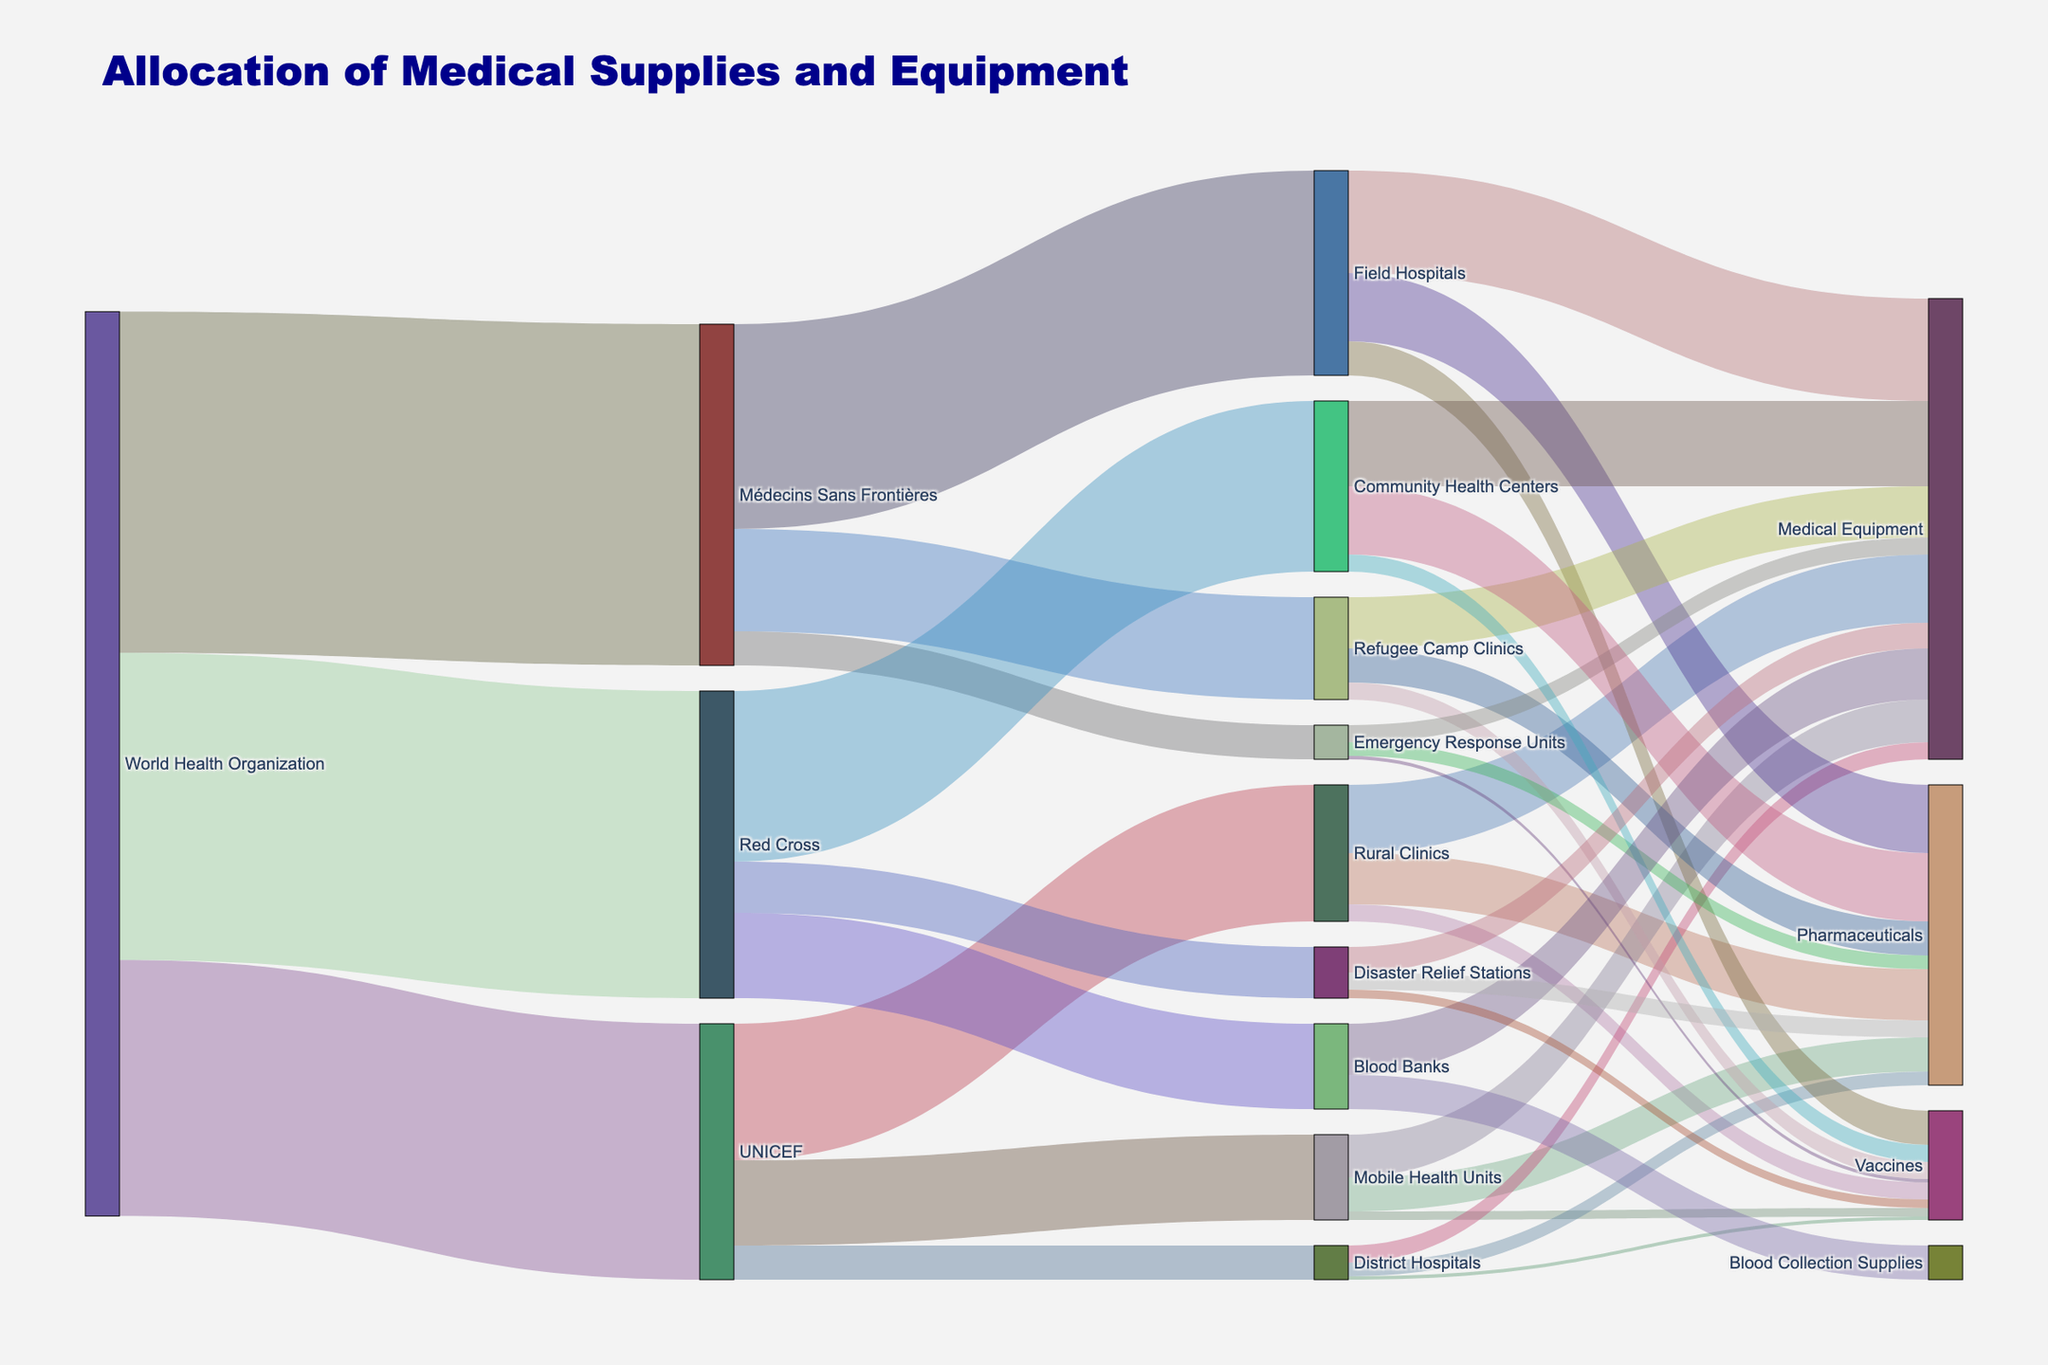Who allocates the most supplies to frontline health facilities? By visually inspecting the flow sizes in the Sankey Diagram, Médecins Sans Frontières allocates the most, as their combined flow to Field Hospitals, Refugee Camp Clinics, and Emergency Response Units is the largest.
Answer: Médecins Sans Frontières Which target facility receives the highest allocation from UNICEF? By inspecting the flows from UNICEF to its target facilities, Rural Clinics receive the highest allocation, indicated by the largest flow value.
Answer: Rural Clinics How much total value is allocated from the World Health Organization to its target organizations? Adding the flows from the World Health Organization to its targets: 1,500,000 + 2,000,000 + 1,800,000 = 5,300,000.
Answer: 5,300,000 Compare the allocation to Field Hospitals from Médecins Sans Frontières and the allocation to Community Health Centers from Red Cross. Which is higher and by how much? Médecins Sans Frontières allocates 1,200,000 to Field Hospitals, whereas Red Cross allocates 1,000,000 to Community Health Centers, resulting in a difference of 200,000.
Answer: Field Hospitals by 200,000 What is the smallest allocation made by UNICEF, and to which facility does it go? Checking the values of the flows from UNICEF, the smallest allocation is 200,000, and it goes to District Hospitals.
Answer: District Hospitals Which type of medical supply receives the highest total allocation? Summing the values for Medical Equipment across all facilities: 400,000 + 250,000 + 100,000 + 600,000 + 300,000 + 100,000 + 500,000 + 300,000 + 150,000 = 2,700,000, indicating the highest allocation.
Answer: Medical Equipment How does the flow from UNICEF to Mobile Health Units compare with the flow from Médecins Sans Frontières to Emergency Response Units? The flow from UNICEF to Mobile Health Units is 500,000 and from Médecins Sans Frontières to Emergency Response Units is 200,000, showing that UNICEF allocates more by 300,000.
Answer: UNICEF by 300,000 What is the combined allocation of pharmaceuticals by all facilities? Adding the values for Pharmaceuticals across all receiving facilities: 300,000 + 200,000 + 80,000 + 400,000 + 200,000 + 80,000 + 400,000 + 100,000 = 1,760,000.
Answer: 1,760,000 Which organization allocates the least to Blood Banks, and what is the value? Observing the flows to Blood Banks, only the Red Cross allocates to it, and the value is 500,000.
Answer: Red Cross, 500,000 